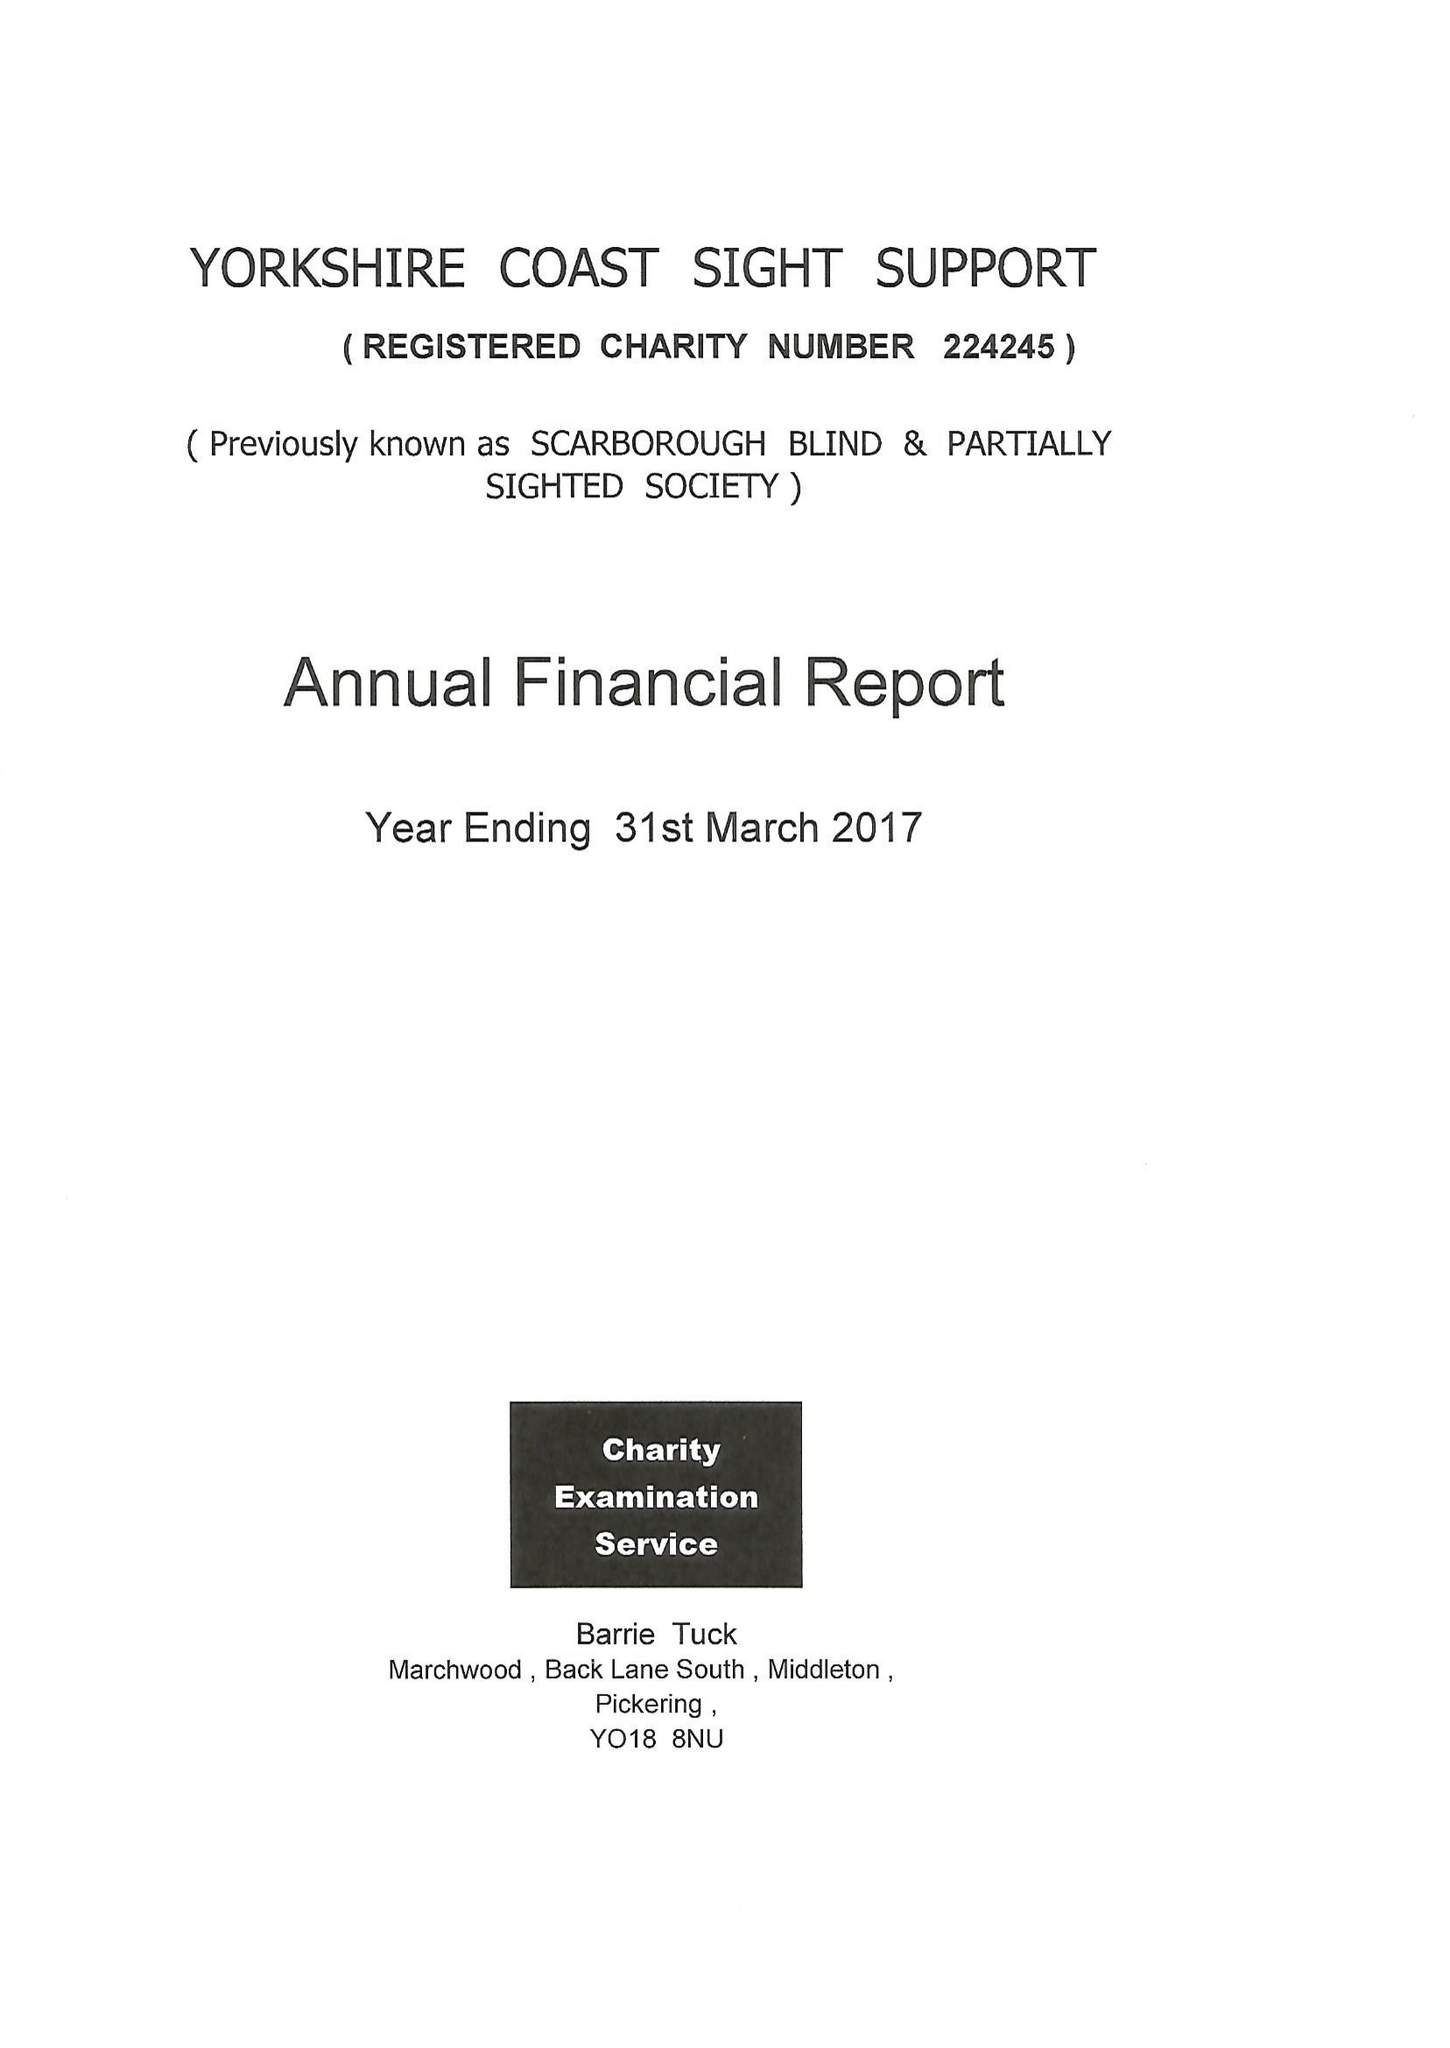What is the value for the charity_number?
Answer the question using a single word or phrase. 224245 